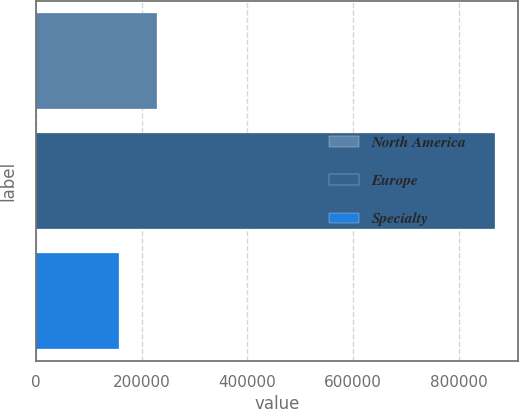Convert chart. <chart><loc_0><loc_0><loc_500><loc_500><bar_chart><fcel>North America<fcel>Europe<fcel>Specialty<nl><fcel>228671<fcel>869136<fcel>157508<nl></chart> 